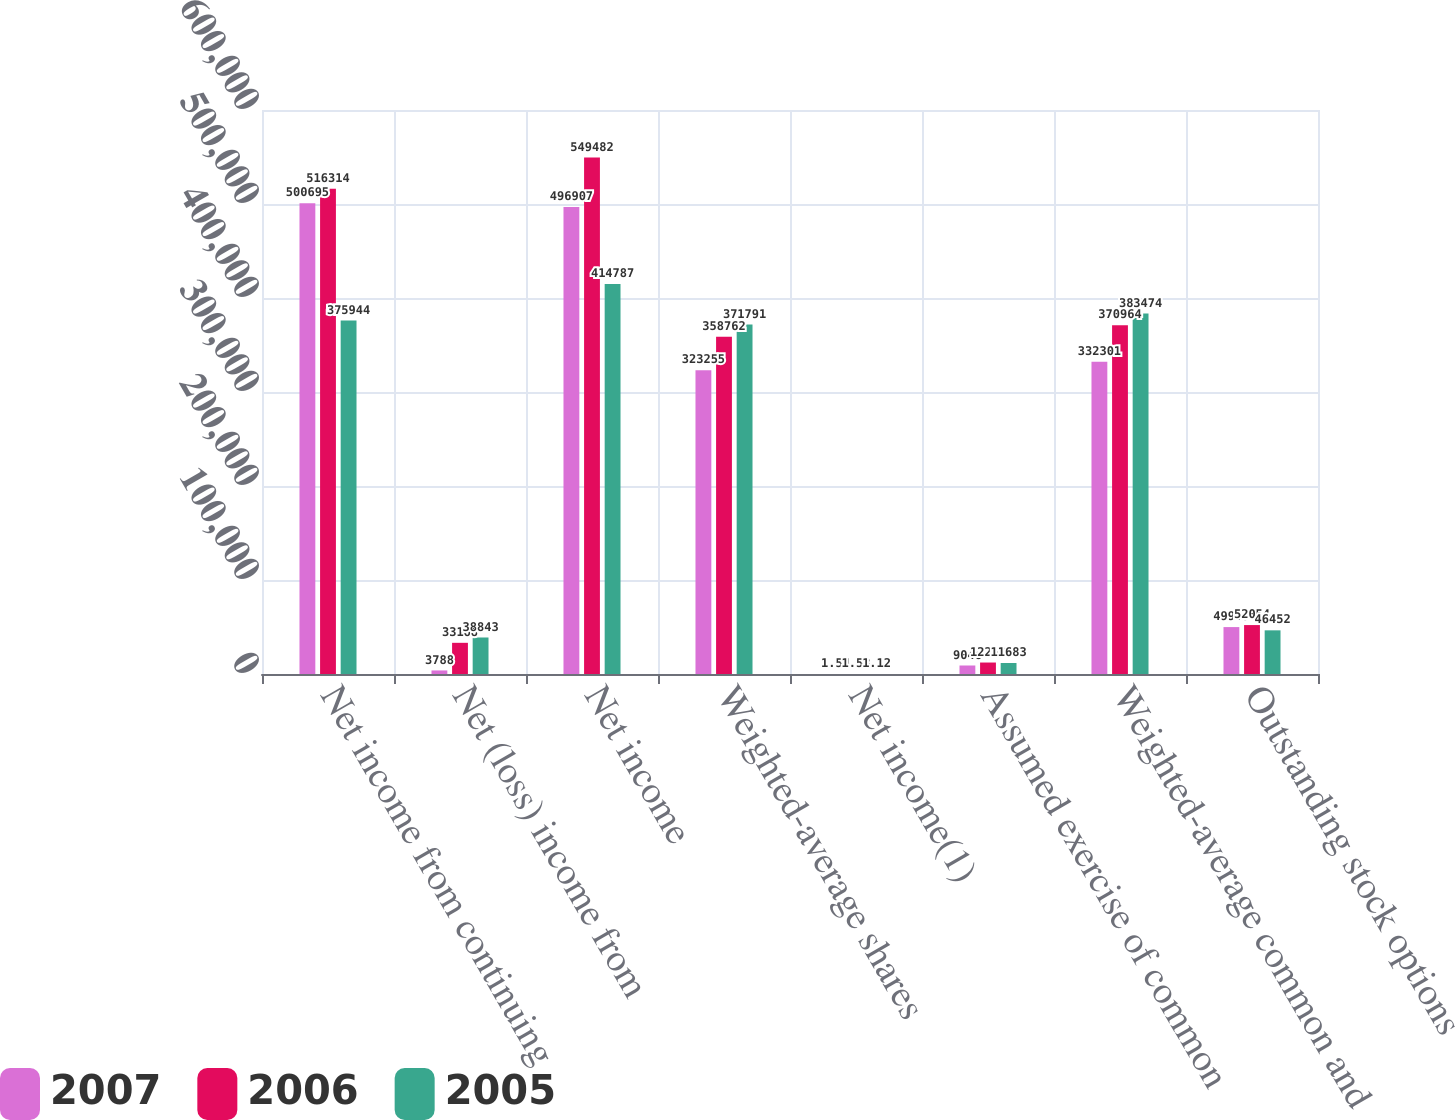Convert chart. <chart><loc_0><loc_0><loc_500><loc_500><stacked_bar_chart><ecel><fcel>Net income from continuing<fcel>Net (loss) income from<fcel>Net income<fcel>Weighted-average shares<fcel>Net income(1)<fcel>Assumed exercise of common<fcel>Weighted-average common and<fcel>Outstanding stock options<nl><fcel>2007<fcel>500695<fcel>3788<fcel>496907<fcel>323255<fcel>1.54<fcel>9046<fcel>332301<fcel>49915<nl><fcel>2006<fcel>516314<fcel>33168<fcel>549482<fcel>358762<fcel>1.53<fcel>12202<fcel>370964<fcel>52054<nl><fcel>2005<fcel>375944<fcel>38843<fcel>414787<fcel>371791<fcel>1.12<fcel>11683<fcel>383474<fcel>46452<nl></chart> 